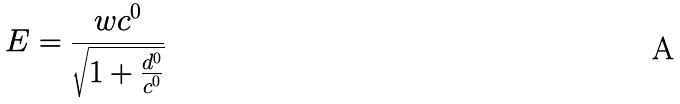<formula> <loc_0><loc_0><loc_500><loc_500>E = \frac { w c ^ { 0 } } { \sqrt { 1 + \frac { d ^ { 0 } } { c ^ { 0 } } } }</formula> 